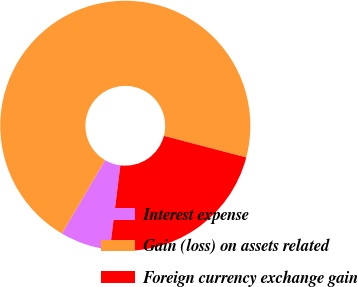Convert chart. <chart><loc_0><loc_0><loc_500><loc_500><pie_chart><fcel>Interest expense<fcel>Gain (loss) on assets related<fcel>Foreign currency exchange gain<nl><fcel>6.49%<fcel>70.61%<fcel>22.9%<nl></chart> 